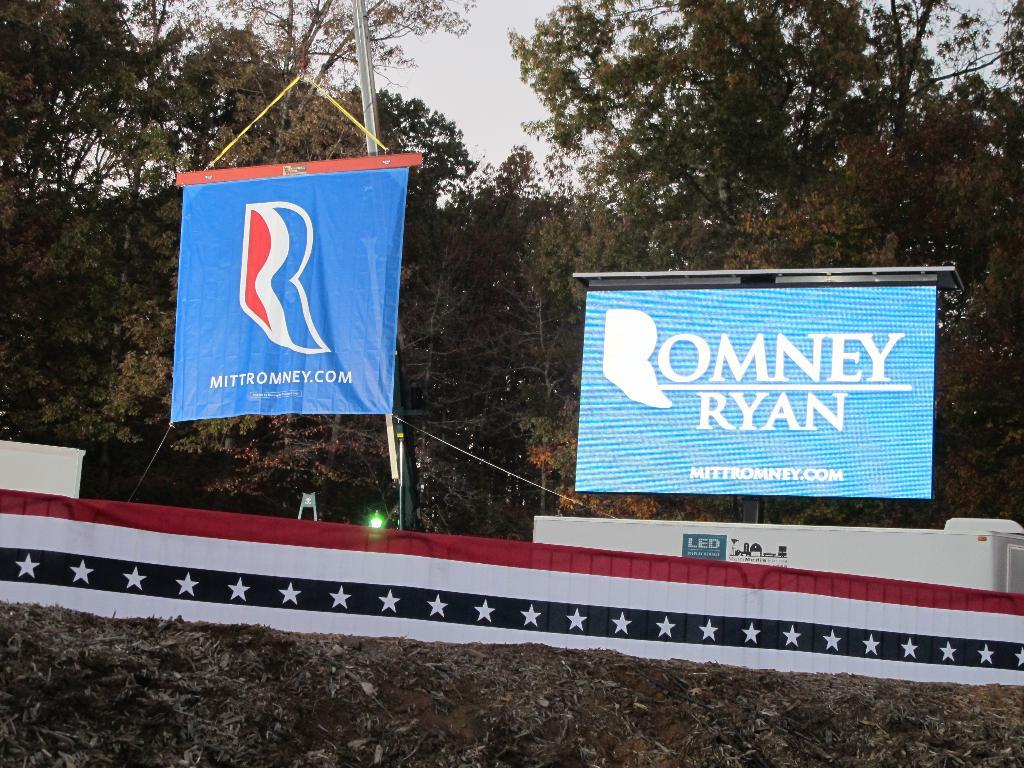Provide a one-sentence caption for the provided image. A blue sign showing support for Romney and Ryan is on top of stage. 